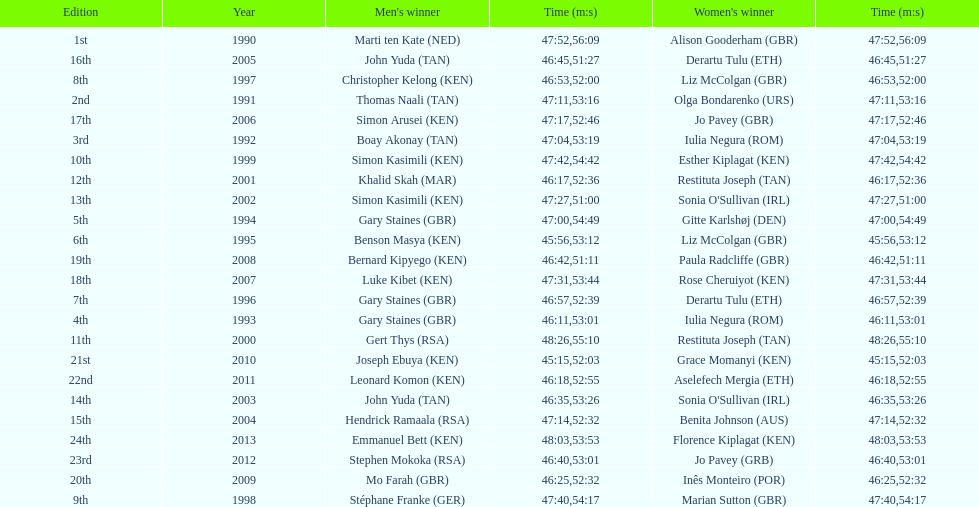Who has the fastest recorded finish for the men's bupa great south run, between 1990 and 2013? Joseph Ebuya (KEN). 